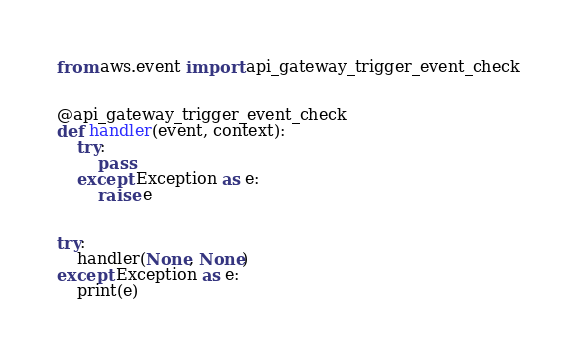<code> <loc_0><loc_0><loc_500><loc_500><_Python_>from aws.event import api_gateway_trigger_event_check


@api_gateway_trigger_event_check
def handler(event, context):
    try:
        pass
    except Exception as e:
        raise e


try:
    handler(None, None)
except Exception as e:
    print(e)
</code> 